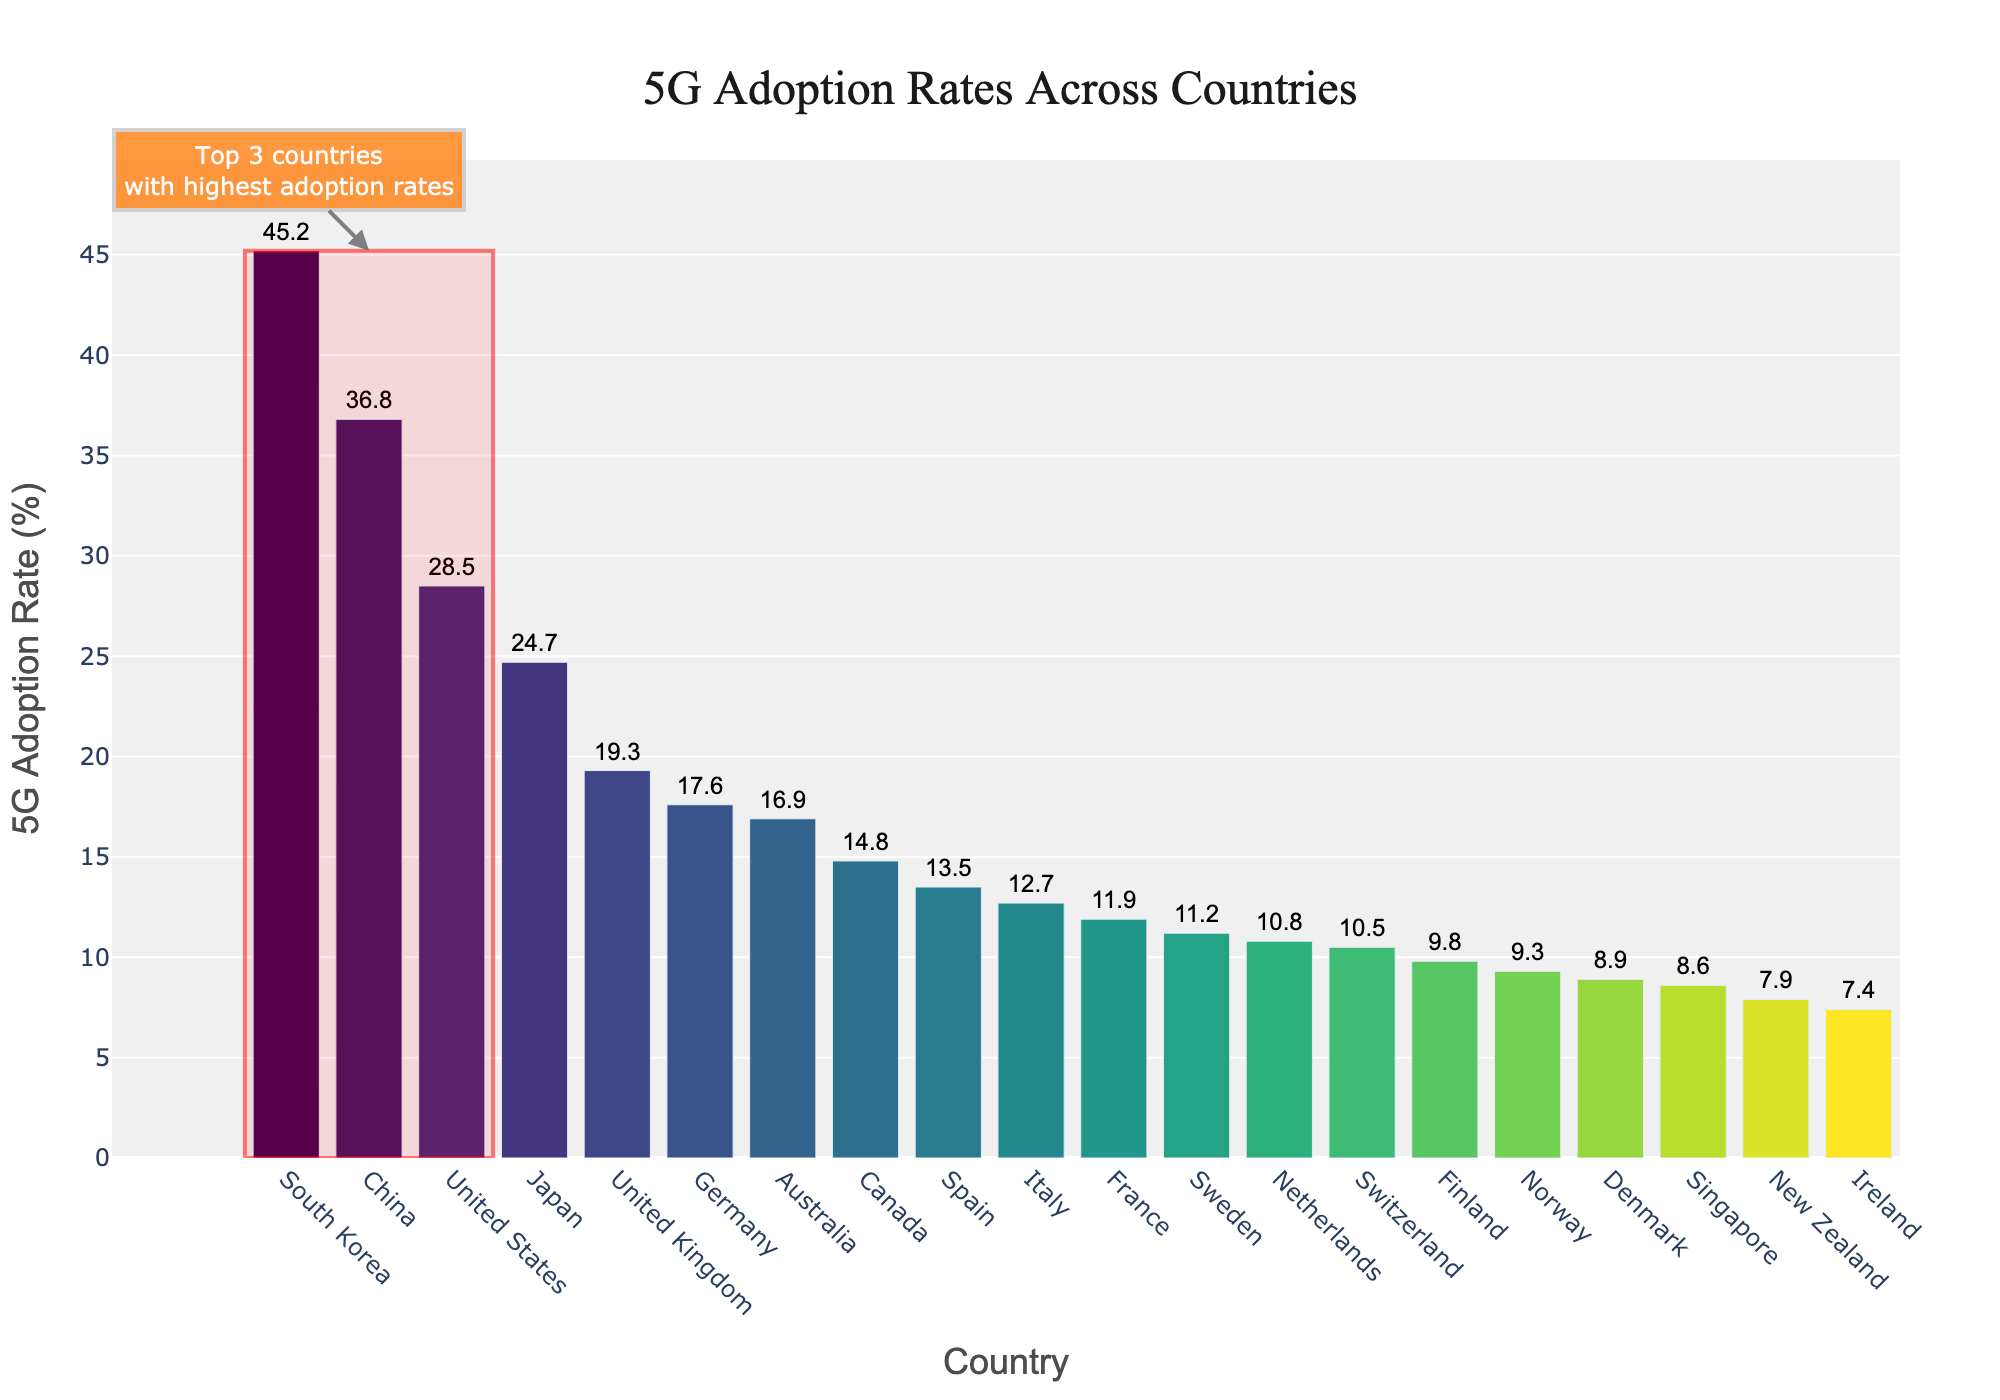What's the 5G adoption rate difference between the highest and the lowest country? Locate South Korea and Ireland, the highest and lowest countries in terms of adoption rates. Subtract Ireland's rate (7.4%) from South Korea's rate (45.2%). The difference is 45.2% - 7.4% = 37.8%.
Answer: 37.8% Which country has a higher 5G adoption rate, Japan or Germany? By how much? Find Japan and Germany's adoption rates, which are 24.7% and 17.6%, respectively. Subtract Germany's rate from Japan's rate: 24.7% - 17.6% = 7.1%. Japan has a higher rate by 7.1%.
Answer: Japan by 7.1% What is the average 5G adoption rate of the top 5 countries? Identify the top 5 countries: South Korea, China, United States, Japan, and United Kingdom. Sum their adoption rates (45.2% + 36.8% + 28.5% + 24.7% + 19.3% = 154.5%) and divide by 5: 154.5% / 5 = 30.9%.
Answer: 30.9% How many countries have a 5G adoption rate higher than 20%? Look at the chart and count the countries with bars extending beyond the 20% mark: South Korea, China, United States, and Japan. There are 4 such countries.
Answer: 4 Which country has the lowest adoption rate in Europe shown in the chart? Examine the countries in Europe from the chart: United Kingdom, Germany, Spain, Italy, France, Sweden, Netherlands, Switzerland, Finland, Norway, and Denmark. Among these, Denmark has the lowest rate at 8.9%.
Answer: Denmark What is the combined 5G adoption rate of Canada and Australia? Locate the rates for Canada (14.8%) and Australia (16.9%). Sum these rates: 14.8% + 16.9% = 31.7%.
Answer: 31.7% Which non-European country has a similar adoption rate to Finland? Identify Finland's rate (9.8%). Look for a non-European country with a close rate: New Zealand has a rate of 7.9%, which is close to Finland's rate.
Answer: New Zealand Which three countries have the highest 5G adoption rates? Observe the chart's top three countries: South Korea (45.2%), China (36.8%), and United States (28.5%).
Answer: South Korea, China, United States What's the color of the bar representing the United States? Look at the bar color for the United States in the chart. It is located in the middle region of the color scale, indicating a yellow-green color.
Answer: Yellow-green 